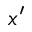<formula> <loc_0><loc_0><loc_500><loc_500>x ^ { \prime }</formula> 